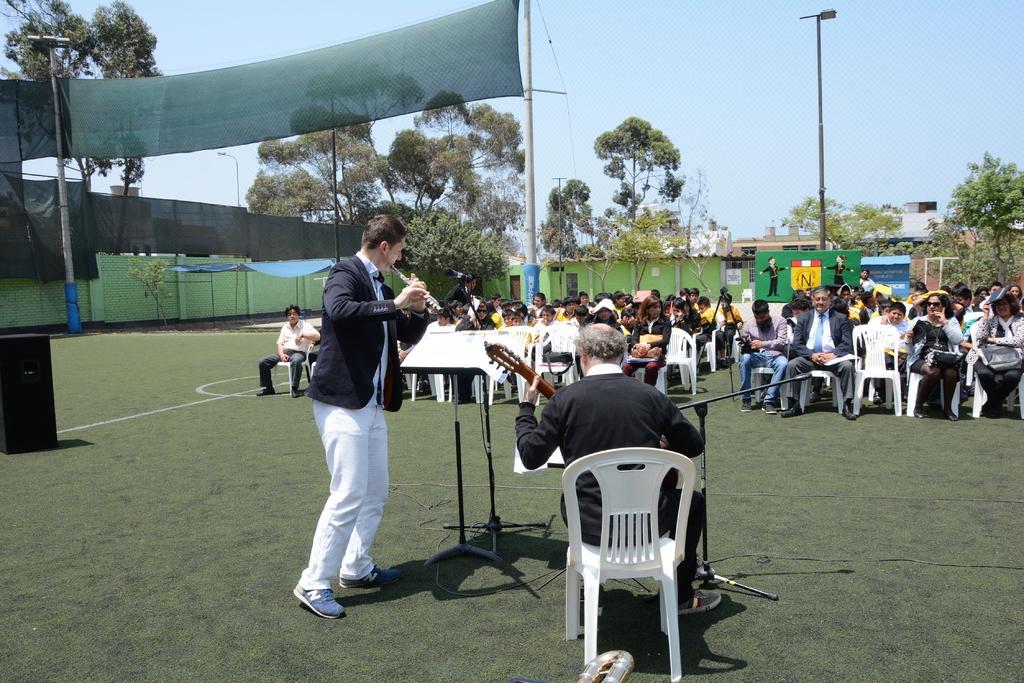Can you describe this image briefly? In the picture I can see a person wearing black dress is sitting and playing guitar and there is another person standing beside him is playing flute and there is a paper placed on a stand in front of him and there are few people sitting in chairs in front of them and there are few trees,buildings and a pole in the background. 